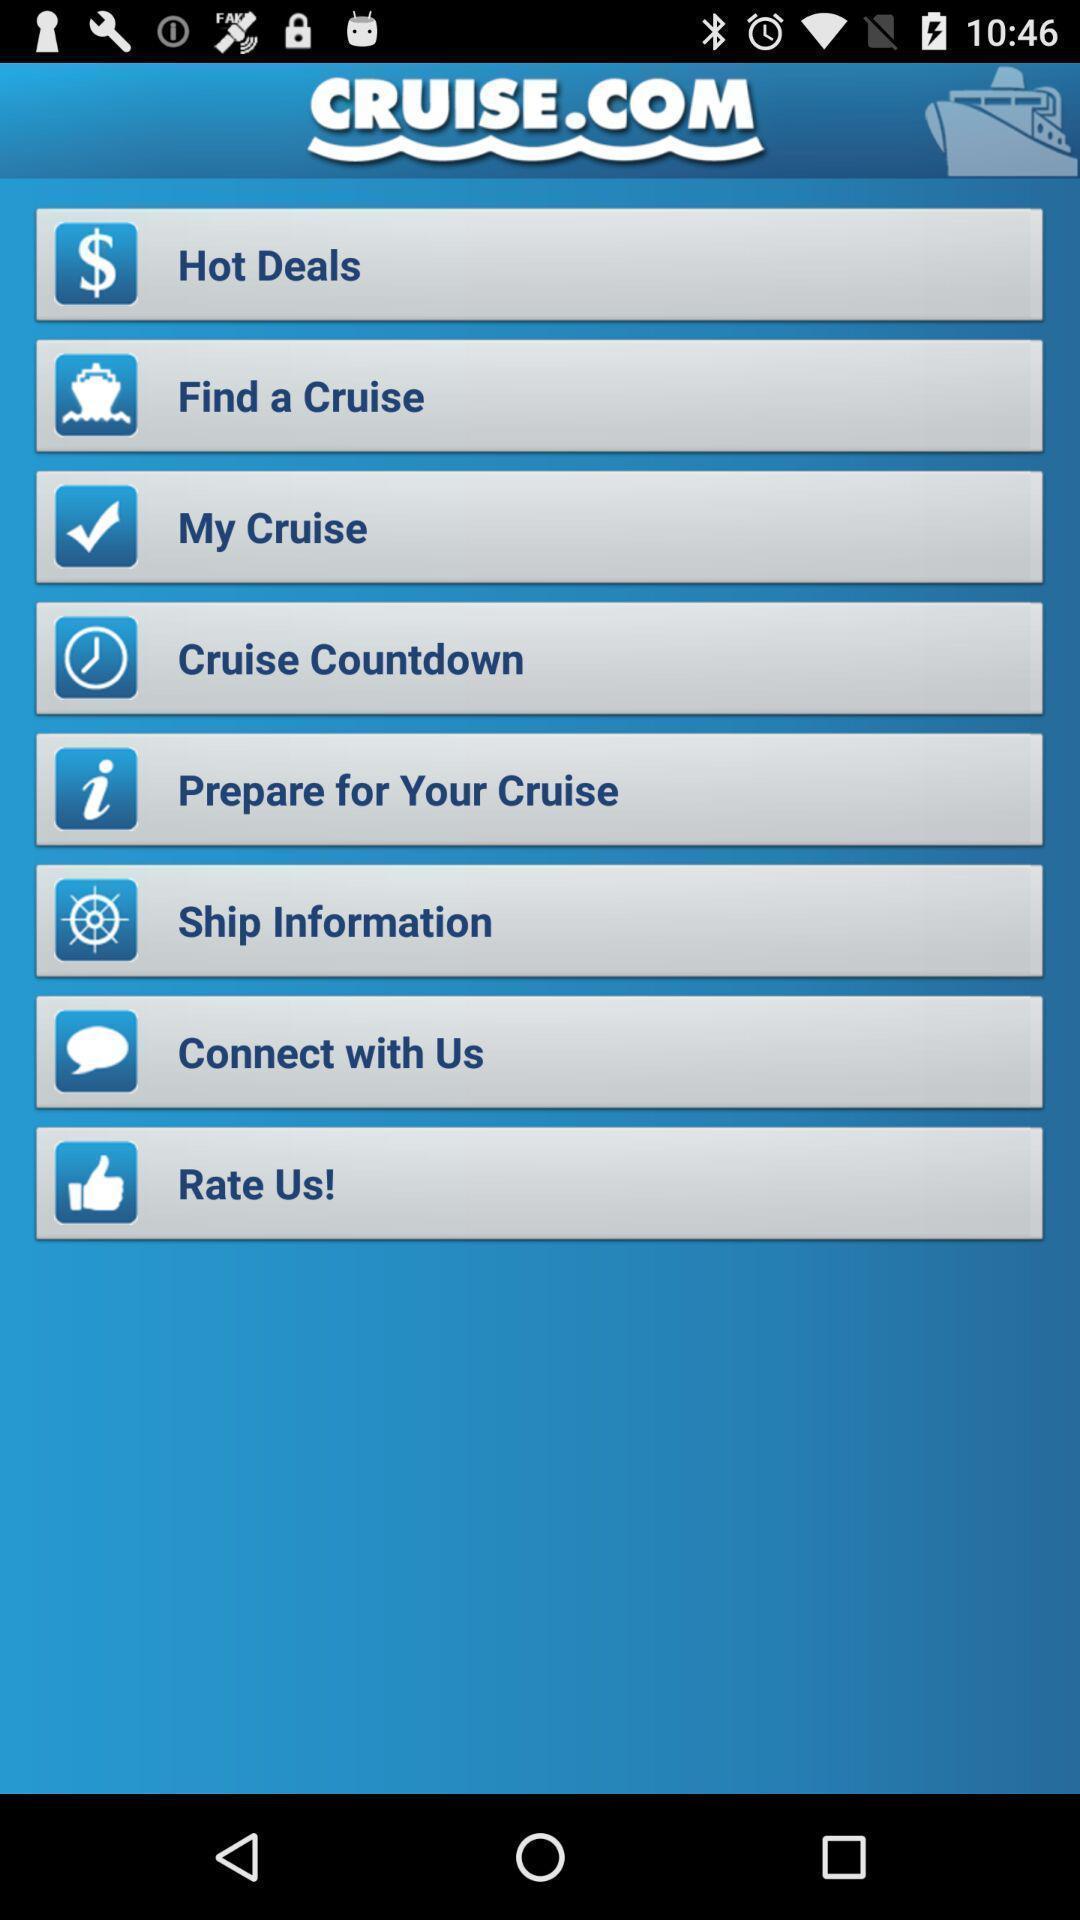Please provide a description for this image. Screen displaying multiple options in a mobile application. 